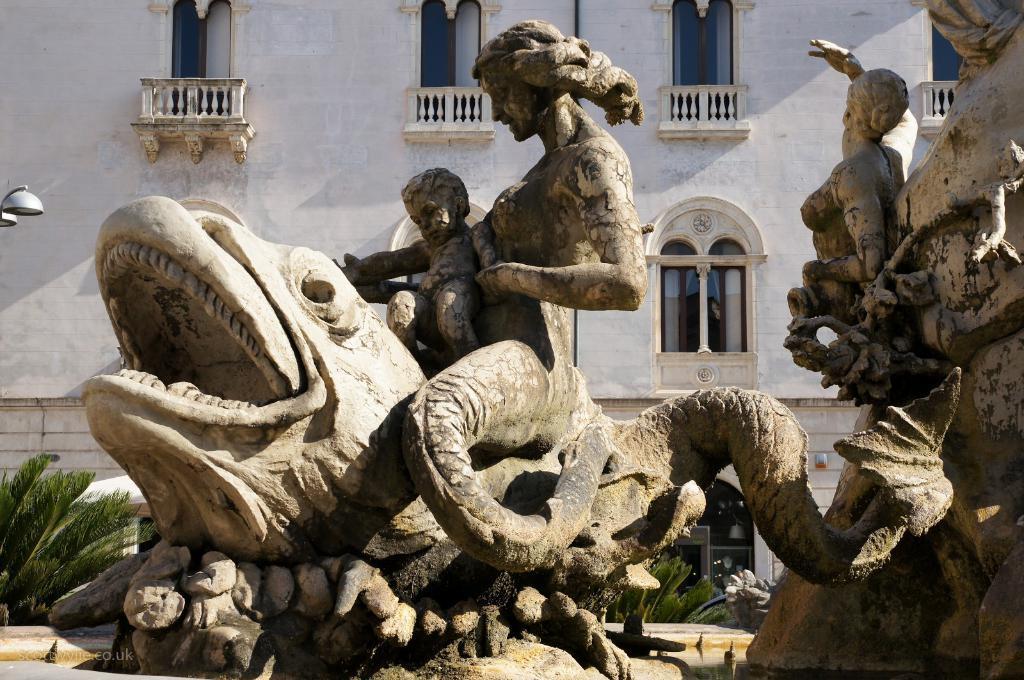How would you summarize this image in a sentence or two? In the center of the image we can see statues. At the bottom left side of the image, there is a watermark. In the background there is a building, windows, fences, plants and a few other objects. 